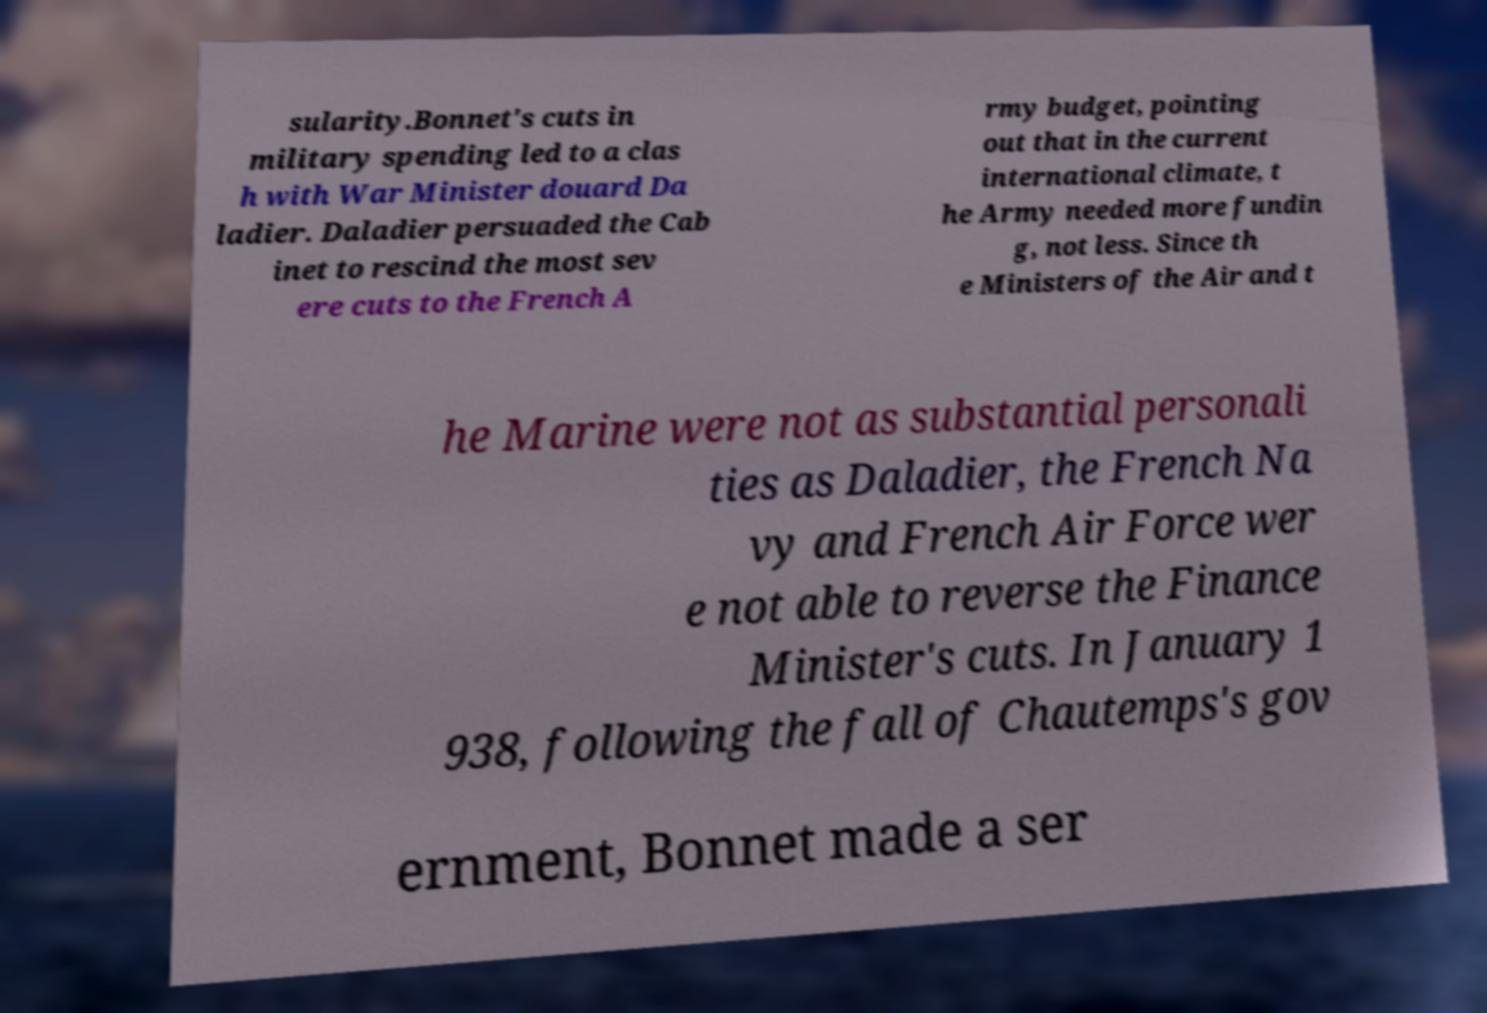Could you assist in decoding the text presented in this image and type it out clearly? sularity.Bonnet's cuts in military spending led to a clas h with War Minister douard Da ladier. Daladier persuaded the Cab inet to rescind the most sev ere cuts to the French A rmy budget, pointing out that in the current international climate, t he Army needed more fundin g, not less. Since th e Ministers of the Air and t he Marine were not as substantial personali ties as Daladier, the French Na vy and French Air Force wer e not able to reverse the Finance Minister's cuts. In January 1 938, following the fall of Chautemps's gov ernment, Bonnet made a ser 